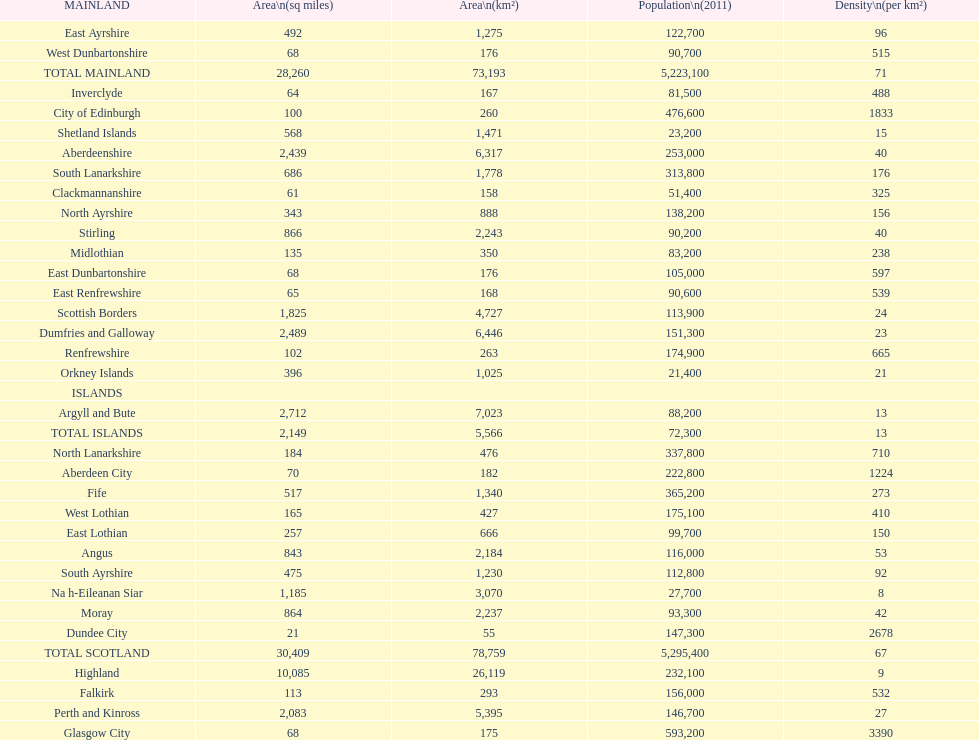What is the difference in square miles between angus and fife? 326. 